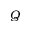Convert formula to latex. <formula><loc_0><loc_0><loc_500><loc_500>Q</formula> 